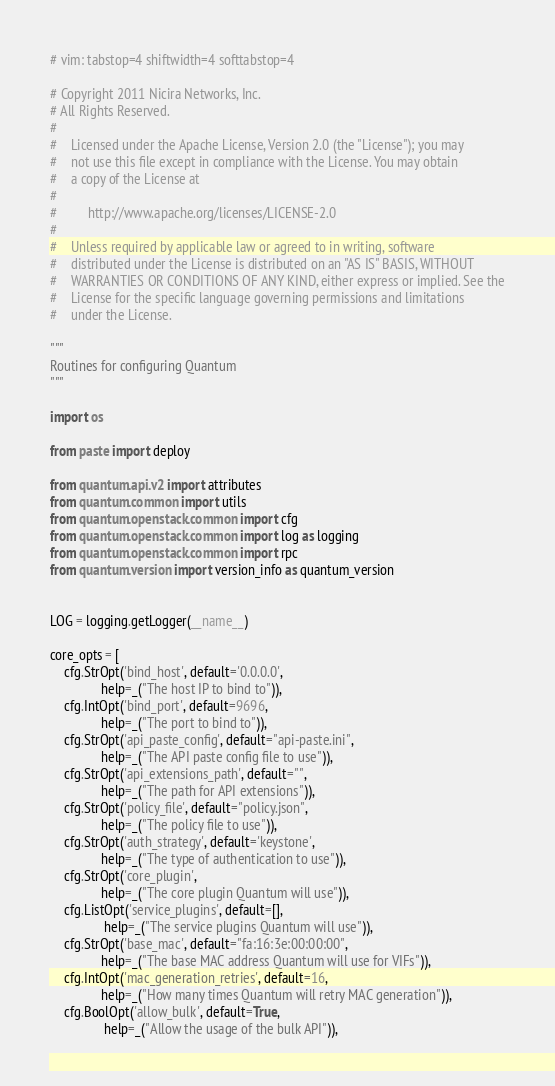<code> <loc_0><loc_0><loc_500><loc_500><_Python_># vim: tabstop=4 shiftwidth=4 softtabstop=4

# Copyright 2011 Nicira Networks, Inc.
# All Rights Reserved.
#
#    Licensed under the Apache License, Version 2.0 (the "License"); you may
#    not use this file except in compliance with the License. You may obtain
#    a copy of the License at
#
#         http://www.apache.org/licenses/LICENSE-2.0
#
#    Unless required by applicable law or agreed to in writing, software
#    distributed under the License is distributed on an "AS IS" BASIS, WITHOUT
#    WARRANTIES OR CONDITIONS OF ANY KIND, either express or implied. See the
#    License for the specific language governing permissions and limitations
#    under the License.

"""
Routines for configuring Quantum
"""

import os

from paste import deploy

from quantum.api.v2 import attributes
from quantum.common import utils
from quantum.openstack.common import cfg
from quantum.openstack.common import log as logging
from quantum.openstack.common import rpc
from quantum.version import version_info as quantum_version


LOG = logging.getLogger(__name__)

core_opts = [
    cfg.StrOpt('bind_host', default='0.0.0.0',
               help=_("The host IP to bind to")),
    cfg.IntOpt('bind_port', default=9696,
               help=_("The port to bind to")),
    cfg.StrOpt('api_paste_config', default="api-paste.ini",
               help=_("The API paste config file to use")),
    cfg.StrOpt('api_extensions_path', default="",
               help=_("The path for API extensions")),
    cfg.StrOpt('policy_file', default="policy.json",
               help=_("The policy file to use")),
    cfg.StrOpt('auth_strategy', default='keystone',
               help=_("The type of authentication to use")),
    cfg.StrOpt('core_plugin',
               help=_("The core plugin Quantum will use")),
    cfg.ListOpt('service_plugins', default=[],
                help=_("The service plugins Quantum will use")),
    cfg.StrOpt('base_mac', default="fa:16:3e:00:00:00",
               help=_("The base MAC address Quantum will use for VIFs")),
    cfg.IntOpt('mac_generation_retries', default=16,
               help=_("How many times Quantum will retry MAC generation")),
    cfg.BoolOpt('allow_bulk', default=True,
                help=_("Allow the usage of the bulk API")),</code> 